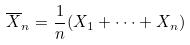<formula> <loc_0><loc_0><loc_500><loc_500>\overline { X } _ { n } = \frac { 1 } { n } ( X _ { 1 } + \cdot \cdot \cdot + X _ { n } )</formula> 